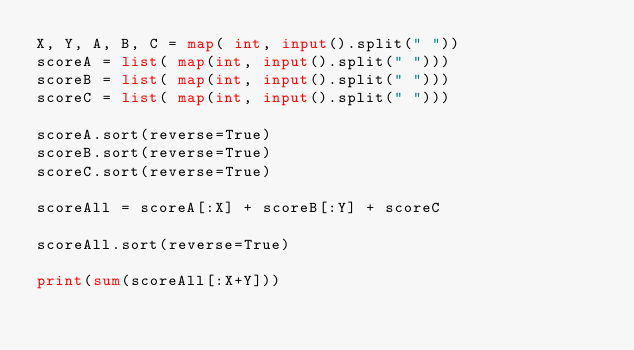Convert code to text. <code><loc_0><loc_0><loc_500><loc_500><_Python_>X, Y, A, B, C = map( int, input().split(" "))
scoreA = list( map(int, input().split(" ")))
scoreB = list( map(int, input().split(" ")))
scoreC = list( map(int, input().split(" ")))

scoreA.sort(reverse=True)
scoreB.sort(reverse=True)
scoreC.sort(reverse=True)

scoreAll = scoreA[:X] + scoreB[:Y] + scoreC

scoreAll.sort(reverse=True)

print(sum(scoreAll[:X+Y]))</code> 